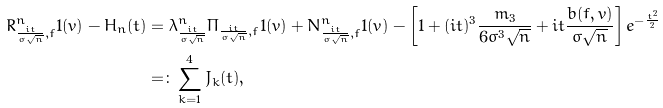<formula> <loc_0><loc_0><loc_500><loc_500>R ^ { n } _ { \frac { i t } { \sigma \sqrt { n } } , f } 1 ( v ) - H _ { n } ( t ) & = \lambda ^ { n } _ { \frac { i t } { \sigma \sqrt { n } } } \Pi _ { \frac { i t } { \sigma \sqrt { n } } , f } 1 ( v ) + N _ { \frac { i t } { \sigma \sqrt { n } } , f } ^ { n } 1 ( v ) - \left [ 1 + ( i t ) ^ { 3 } \frac { m _ { 3 } } { 6 \sigma ^ { 3 } \sqrt { n } } + i t \frac { b ( f , v ) } { \sigma \sqrt { n } } \right ] e ^ { - \frac { t ^ { 2 } } { 2 } } \\ & = \colon \sum _ { k = 1 } ^ { 4 } J _ { k } ( t ) ,</formula> 